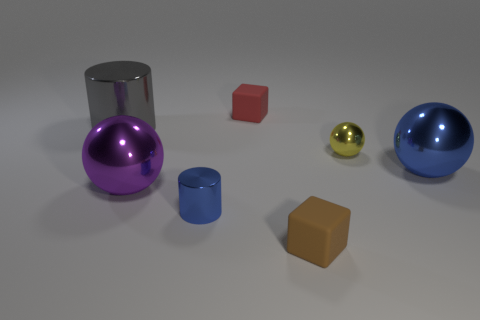Add 1 tiny yellow shiny spheres. How many objects exist? 8 Subtract all blocks. How many objects are left? 5 Subtract 0 red cylinders. How many objects are left? 7 Subtract all brown matte blocks. Subtract all large purple metal spheres. How many objects are left? 5 Add 3 blue balls. How many blue balls are left? 4 Add 1 small blue objects. How many small blue objects exist? 2 